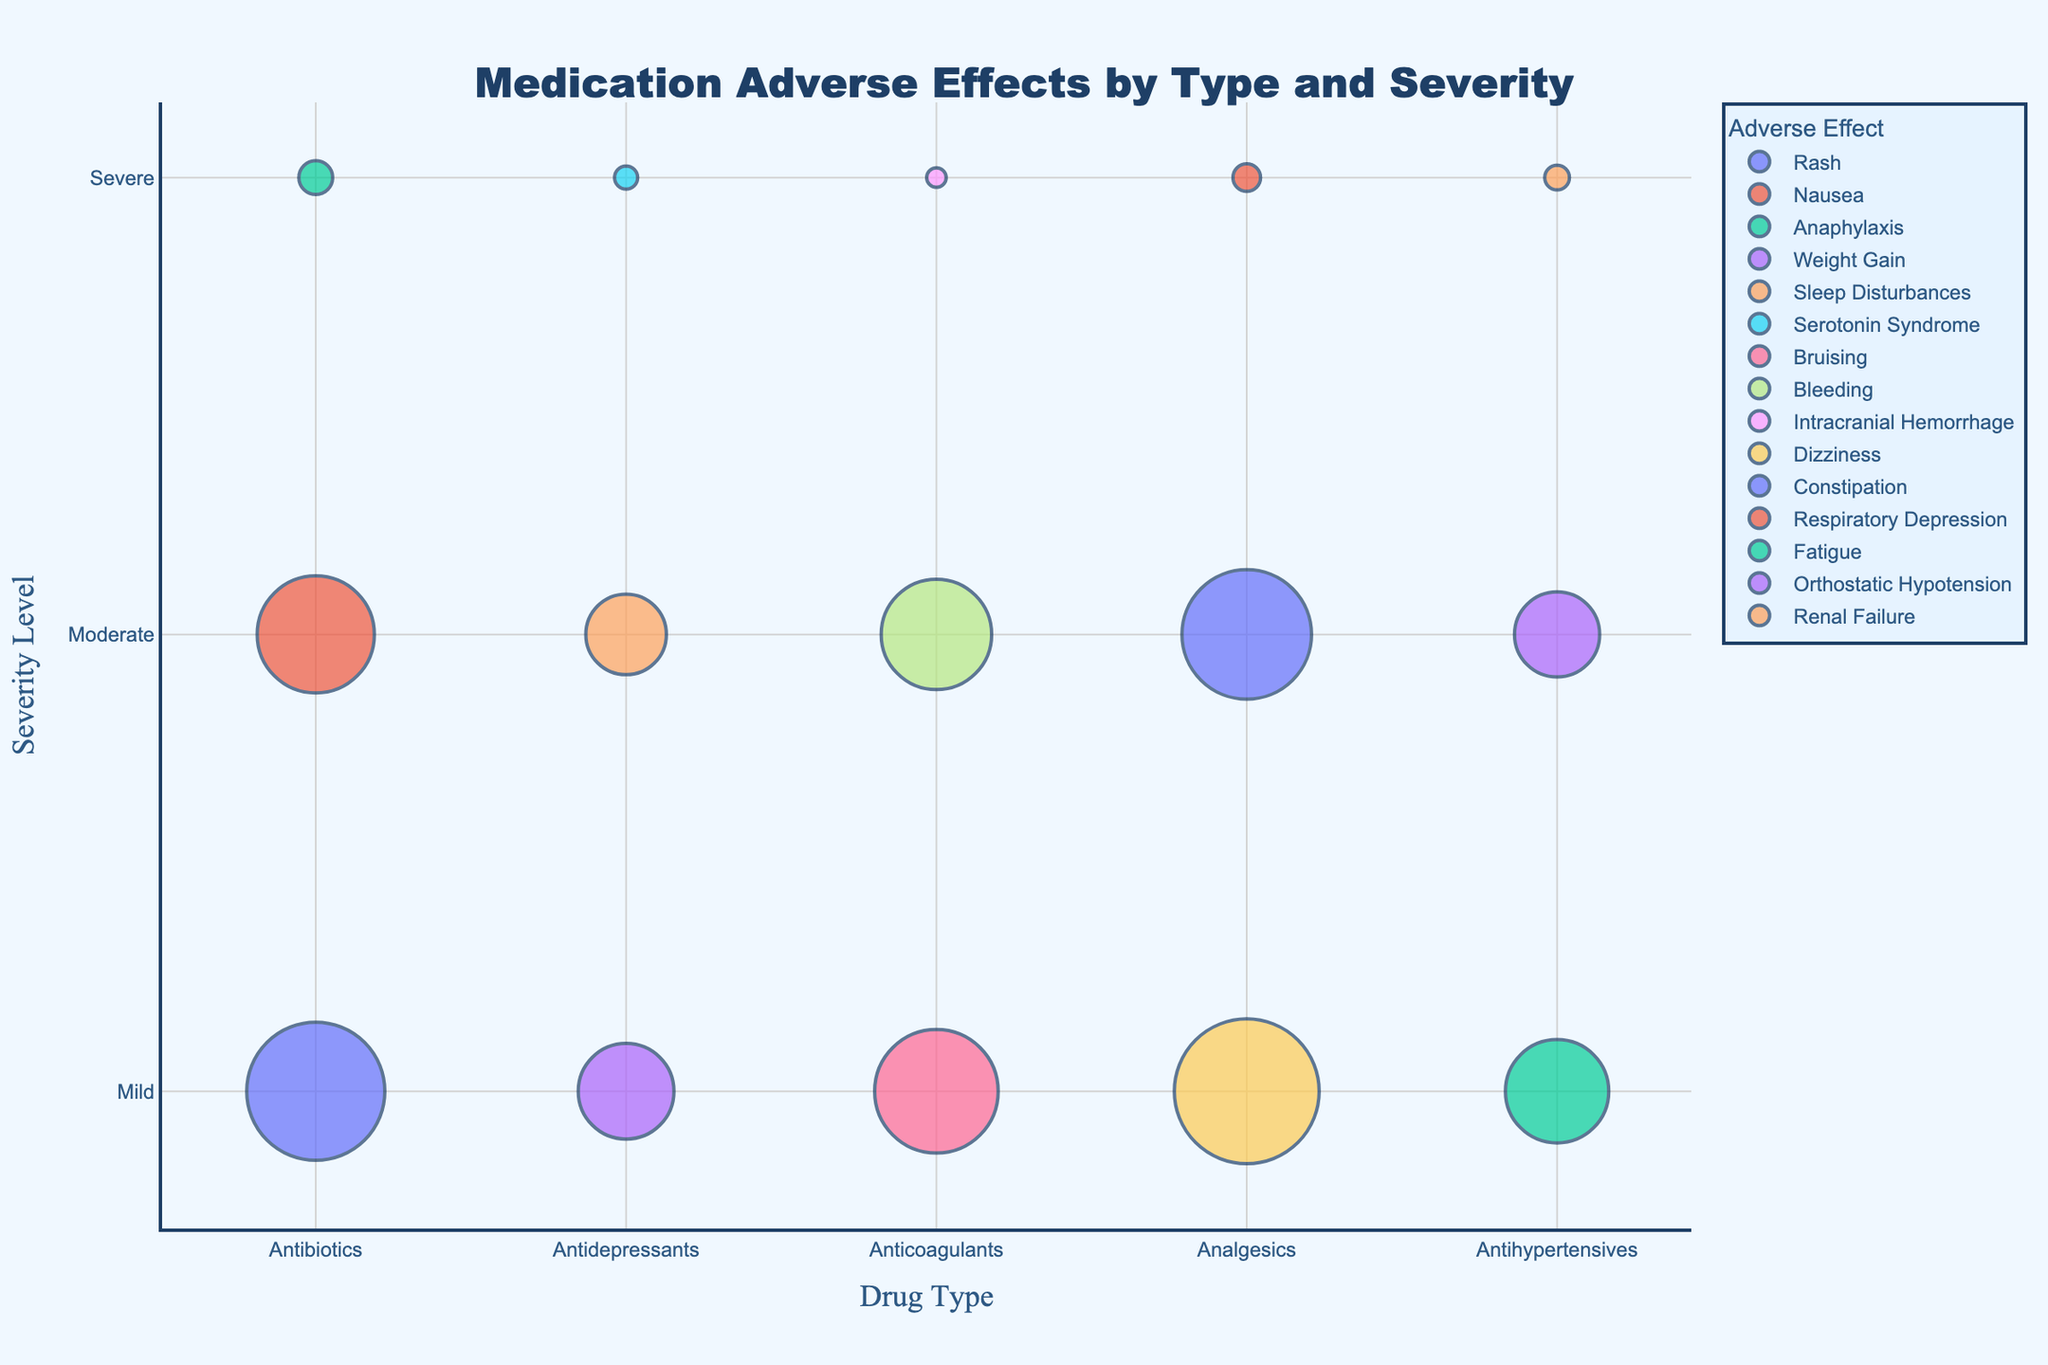Which drug type has the highest number of reports for a mild severity adverse effect? The bubble representing "Dizziness" under "Analgesics" is the largest in the Mild category. This indicates the highest number of reports.
Answer: Analgesics What adverse effect under Antibiotics has the highest number of reports? The largest bubble under the "Antibiotics" category corresponds to "Rash" in the Mild severity level.
Answer: Rash How many total reports are there for severe adverse effects across all drug types? Summing up the sizes of the bubbles in the Severe category, we get 15 (Anaphylaxis) + 7 (Serotonin Syndrome) + 5 (Intracranial Hemorrhage) + 10 (Respiratory Depression) + 8 (Renal Failure) = 45.
Answer: 45 Which drug type has the most adverse effects reported in the moderate severity category? By counting the bubbles in the Moderate category for each drug type, "Analgesics" has three (Analgesics: Dizziness, Constipation, Respiratory Depression).
Answer: Analgesics What's the difference in the number of reports between Antibiotics with a mild severity adverse effect and Anticoagulants with a moderate severity adverse effect? Antibiotics (Rash, Mild) has 250 reports, and Anticoagulants (Bleeding, Moderate) has 160 reports. The difference is 250 - 160 = 90.
Answer: 90 Which adverse effect has the lowest number of reports in the chart? The smallest bubble, which corresponds to "Intracranial Hemorrhage" under "Anticoagulants" in the Severe category, indicates the lowest number of reports.
Answer: Intracranial Hemorrhage Are there any drug types with no severe adverse effects reported? All listed drug types (Antibiotics, Antidepressants, Anticoagulants, Analgesics, Antihypertensives) have bubbles in the Severe category, indicating reports. Hence, none of them have zero severe adverse effect reports.
Answer: No Which adverse effect corresponding to Antidepressants has the second highest number of reports? For Antidepressants, "Weight Gain" (Mild) has 120 reports and "Sleep Disturbances" (Moderate) has 85 reports. "Sleep Disturbances" is the second highest.
Answer: Sleep Disturbances How many adverse effects in the chart have more than 200 reports? From the chart, three bubbles have more than 200 reports: "Rash" (250), "Dizziness" (275), and "Constipation" (220).
Answer: 3 